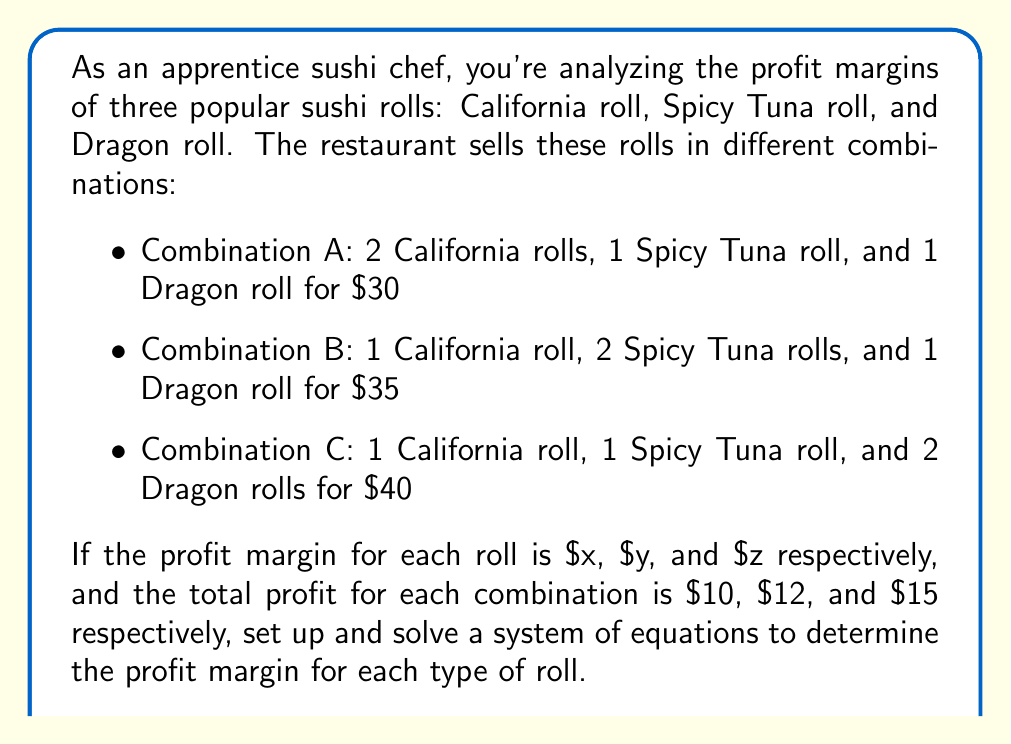Solve this math problem. Let's approach this step-by-step:

1) First, let's define our variables:
   $x$ = profit margin for California roll
   $y$ = profit margin for Spicy Tuna roll
   $z$ = profit margin for Dragon roll

2) Now, we can set up our system of equations based on the given information:

   Equation 1: $2x + y + z = 10$ (Combination A)
   Equation 2: $x + 2y + z = 12$ (Combination B)
   Equation 3: $x + y + 2z = 15$ (Combination C)

3) To solve this system, we can use the elimination method:

4) Subtract Equation 1 from Equation 2:
   $(x + 2y + z) - (2x + y + z) = 12 - 10$
   $-x + y = 2$ ... (Equation 4)

5) Subtract Equation 1 from Equation 3:
   $(x + y + 2z) - (2x + y + z) = 15 - 10$
   $-x + z = 5$ ... (Equation 5)

6) From Equation 4: $y = 2 + x$
   From Equation 5: $z = 5 + x$

7) Substitute these into Equation 1:
   $2x + (2 + x) + (5 + x) = 10$
   $2x + 2 + x + 5 + x = 10$
   $4x + 7 = 10$
   $4x = 3$
   $x = 3/4 = 0.75$

8) Now we can find y and z:
   $y = 2 + x = 2 + 0.75 = 2.75$
   $z = 5 + x = 5 + 0.75 = 5.75$

Therefore, the profit margins are:
California roll: $0.75
Spicy Tuna roll: $2.75
Dragon roll: $5.75
Answer: The profit margins are:
California roll: $0.75
Spicy Tuna roll: $2.75
Dragon roll: $5.75 